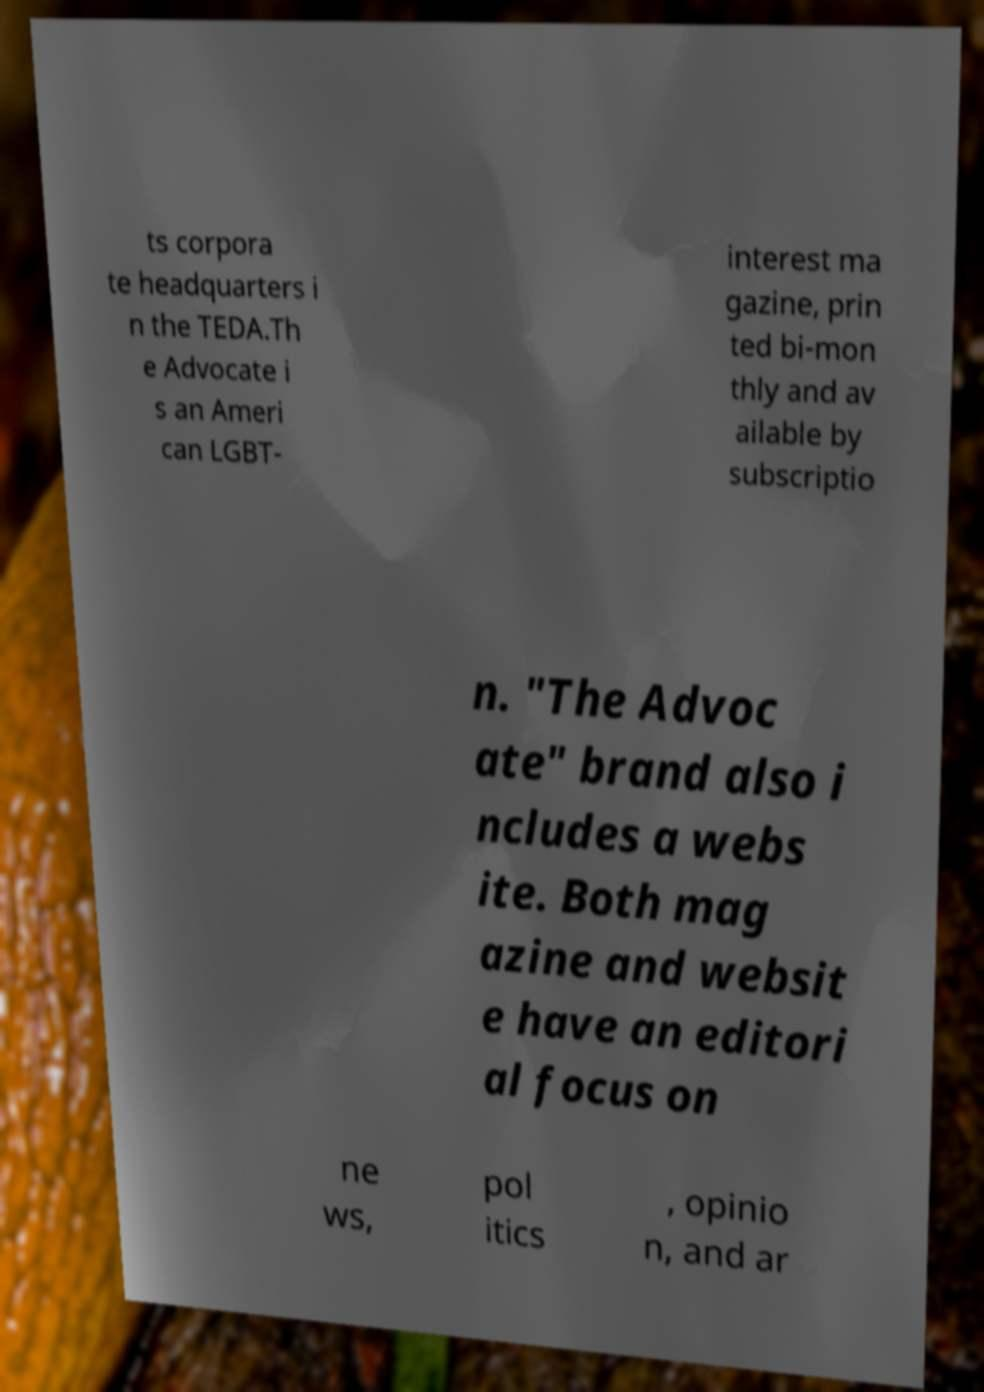Could you assist in decoding the text presented in this image and type it out clearly? ts corpora te headquarters i n the TEDA.Th e Advocate i s an Ameri can LGBT- interest ma gazine, prin ted bi-mon thly and av ailable by subscriptio n. "The Advoc ate" brand also i ncludes a webs ite. Both mag azine and websit e have an editori al focus on ne ws, pol itics , opinio n, and ar 